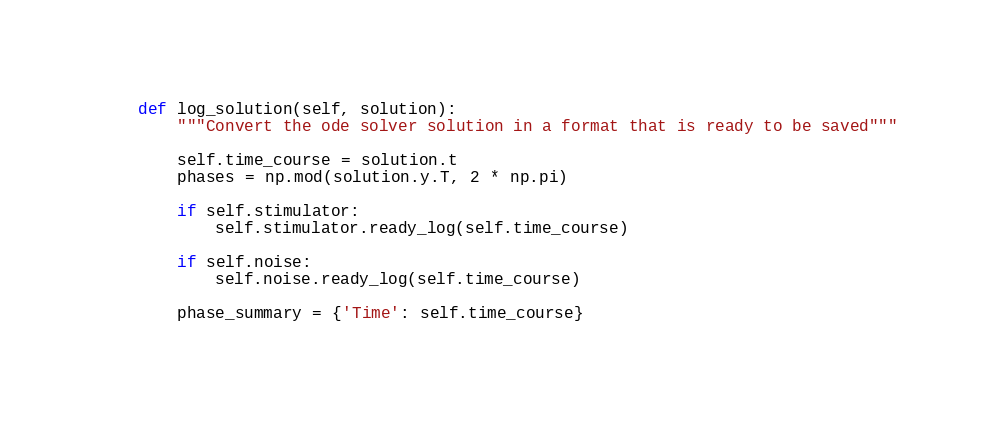Convert code to text. <code><loc_0><loc_0><loc_500><loc_500><_Python_>
    def log_solution(self, solution):
        """Convert the ode solver solution in a format that is ready to be saved"""

        self.time_course = solution.t
        phases = np.mod(solution.y.T, 2 * np.pi)

        if self.stimulator:
            self.stimulator.ready_log(self.time_course)

        if self.noise:
            self.noise.ready_log(self.time_course)

        phase_summary = {'Time': self.time_course}</code> 